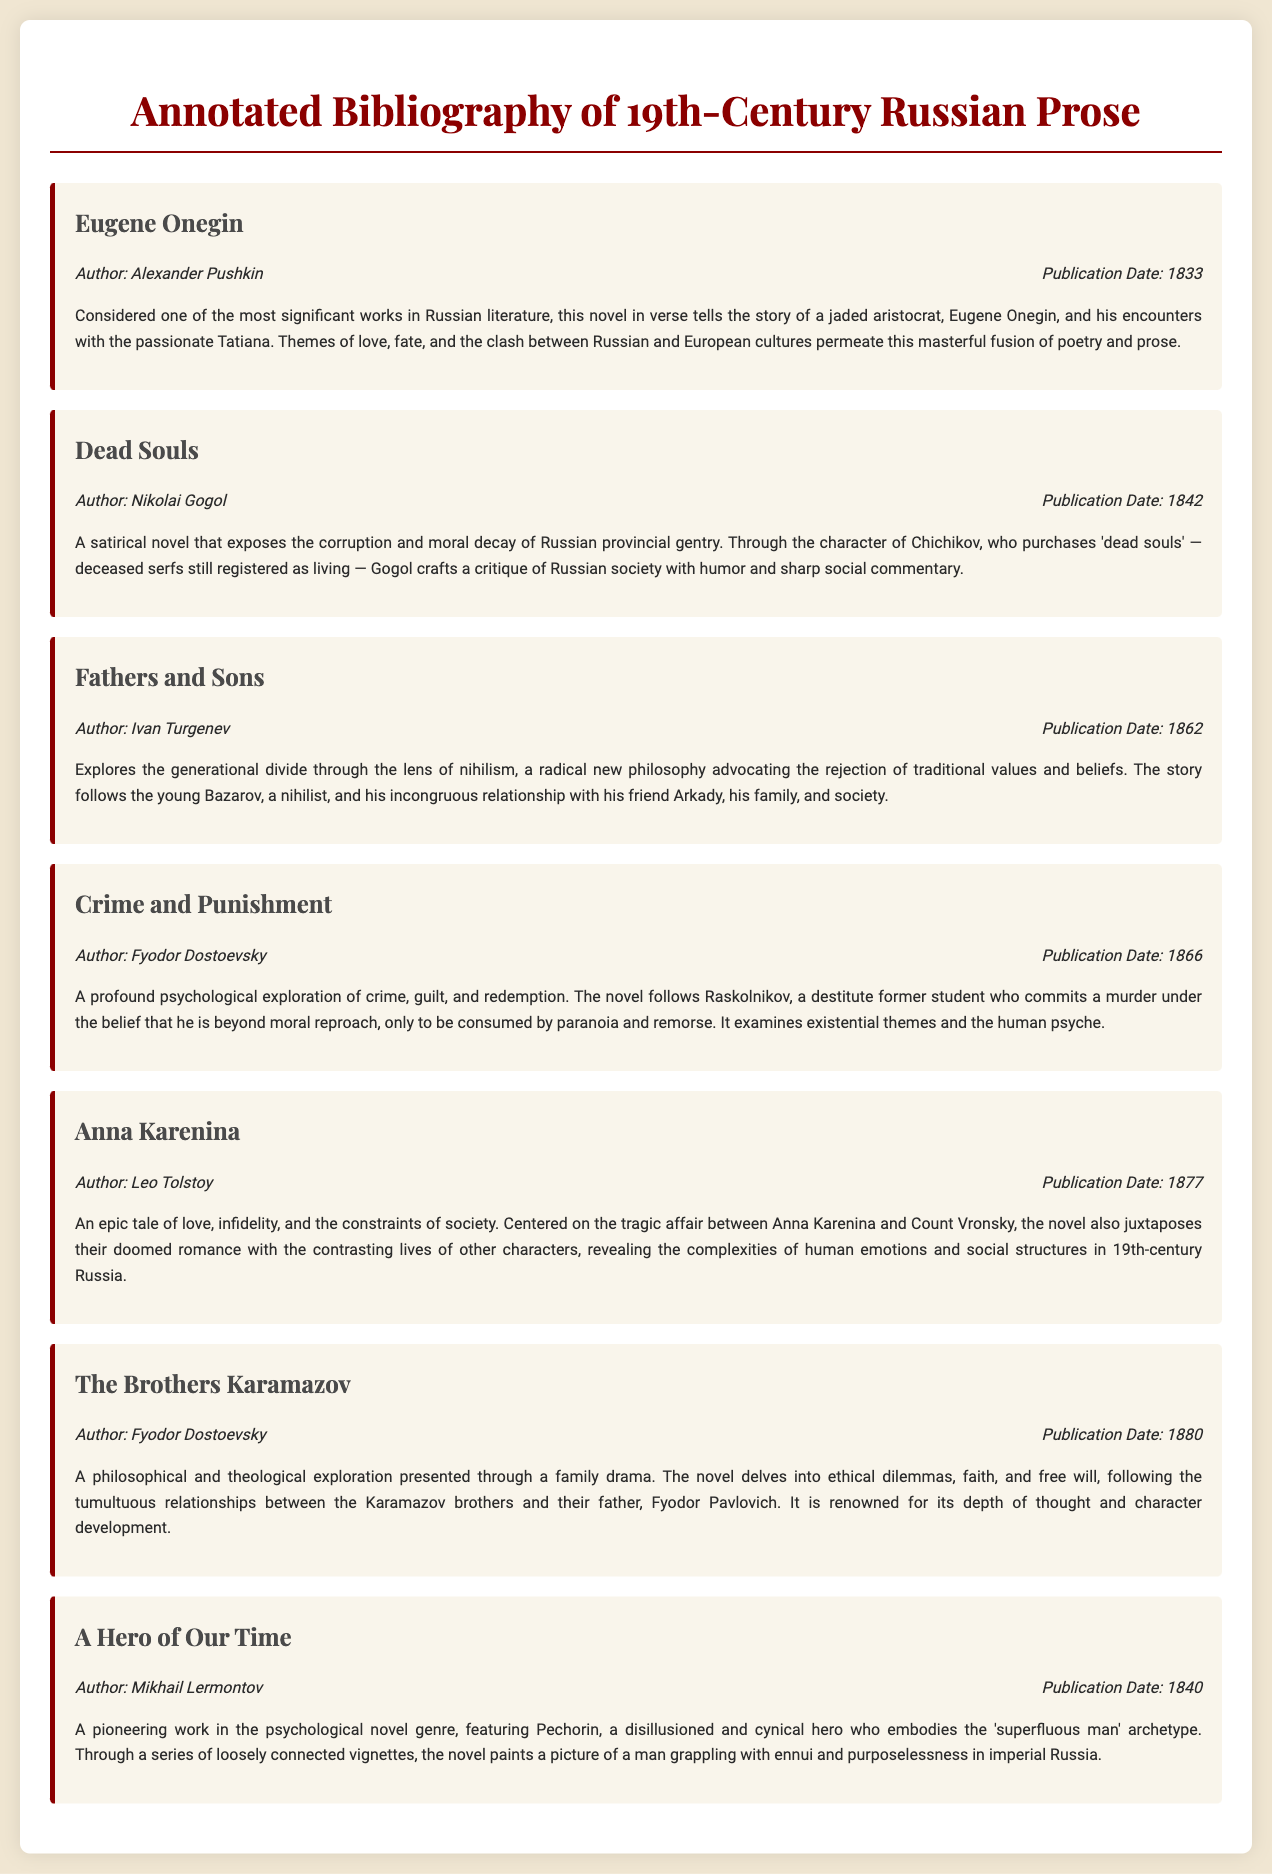What is the title of the book by Alexander Pushkin? The title of the book is mentioned directly in the document as "Eugene Onegin."
Answer: Eugene Onegin What year was "Dead Souls" published? The publication date for "Dead Souls" is explicitly stated in the document as 1842.
Answer: 1842 Who is the author of "Crime and Punishment"? The document provides the author's name, which is Fyodor Dostoevsky for "Crime and Punishment."
Answer: Fyodor Dostoevsky What is the main theme of "Anna Karenina"? The document summarizes the main theme, focusing on love, infidelity, and societal constraints.
Answer: Love, infidelity, and societal constraints Which book addresses nihilism? The question refers to a theme explicitly connected in the document with "Fathers and Sons."
Answer: Fathers and Sons How many books are listed in the bibliography? The document displays a total of six distinct works listed in the annotated bibliography.
Answer: Six What publication year appeared first in the document? The earliest mentioned publication date in the document is provided for "Eugene Onegin," which is 1833.
Answer: 1833 What character archetype does Pechorin represent? In the document, Pechorin is described as embodying the 'superfluous man' archetype.
Answer: Superfluous man Which author has written multiple works in this bibliography? The document indicates that Fyodor Dostoevsky has authored more than one listed book, specifically "Crime and Punishment" and "The Brothers Karamazov."
Answer: Fyodor Dostoevsky 